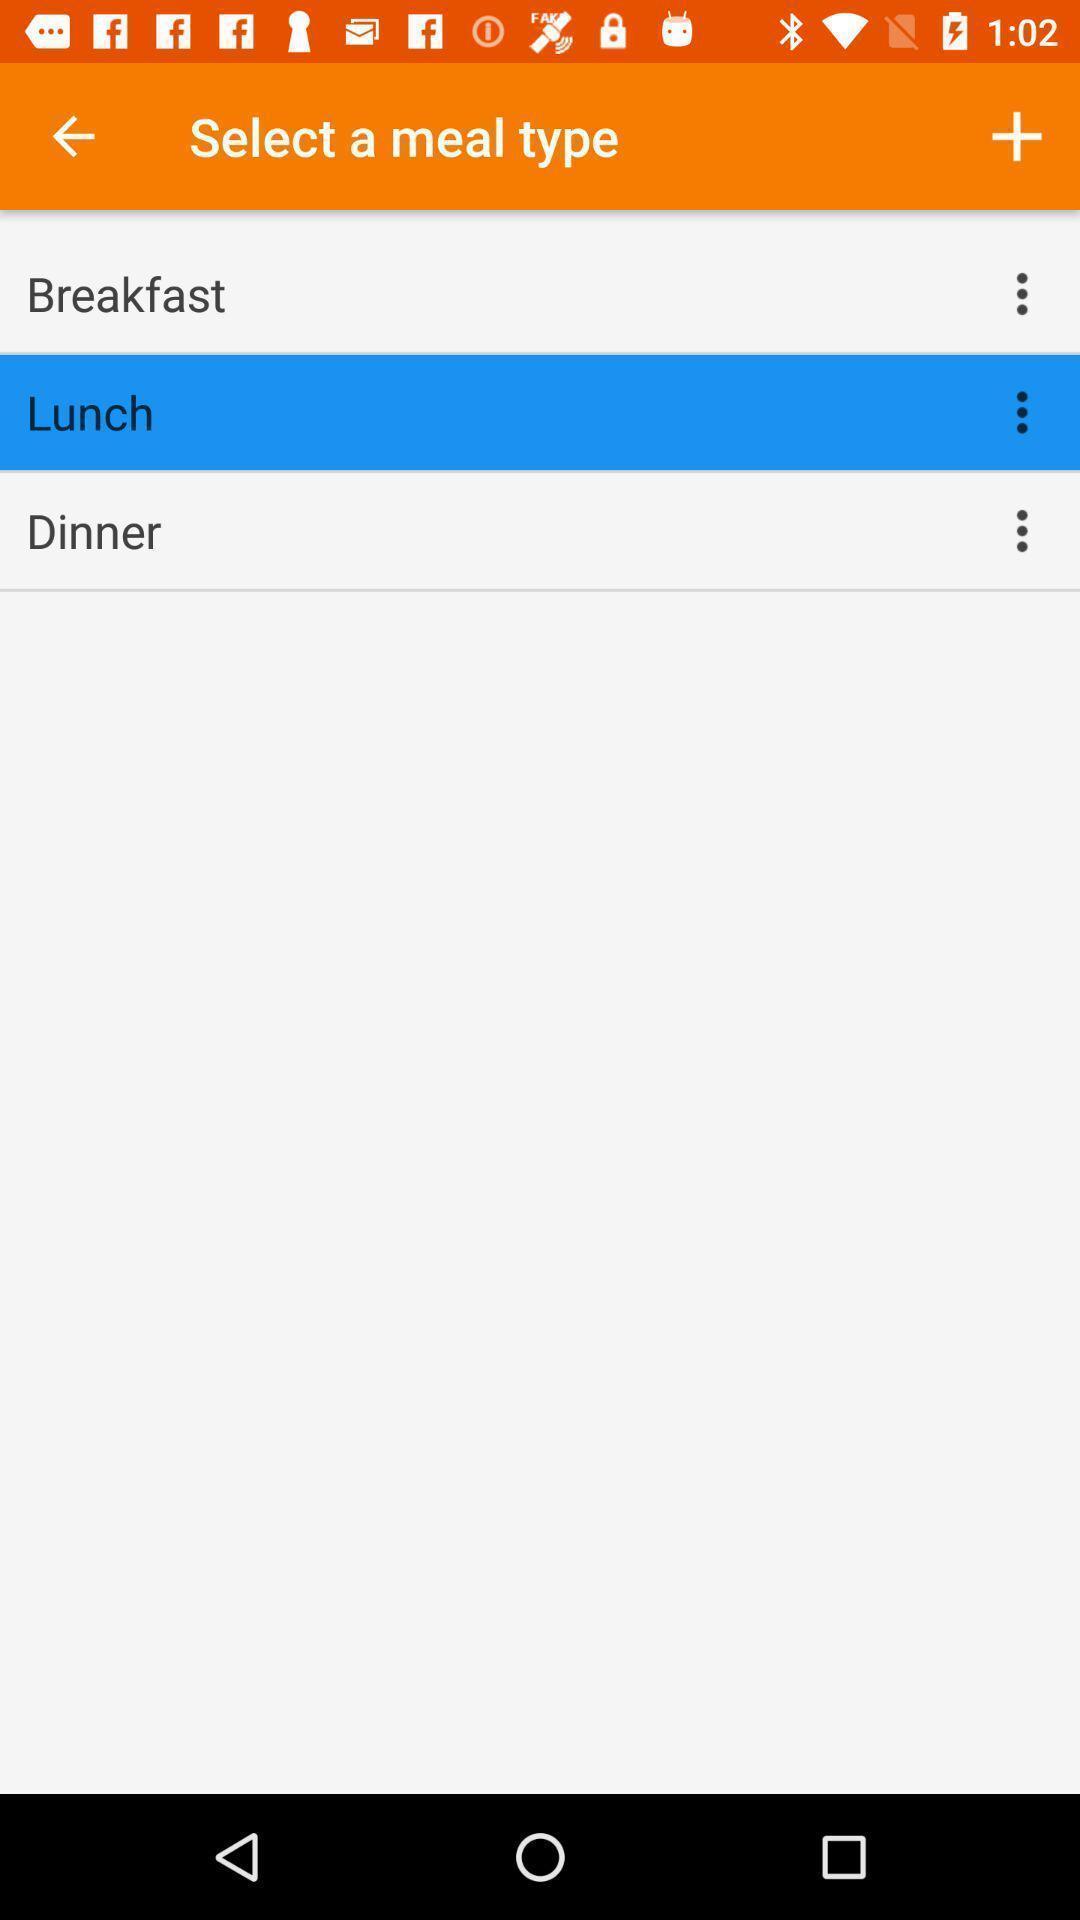Please provide a description for this image. Window displaying a meal planner app. 